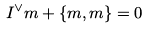Convert formula to latex. <formula><loc_0><loc_0><loc_500><loc_500>I ^ { \vee } m + \{ m , m \} = 0</formula> 